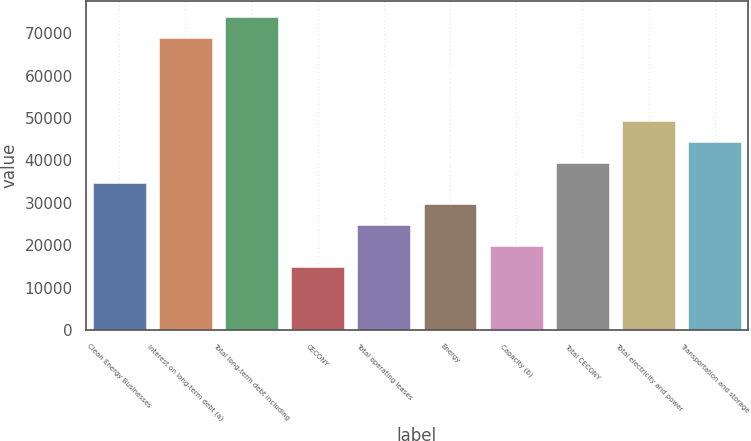Convert chart to OTSL. <chart><loc_0><loc_0><loc_500><loc_500><bar_chart><fcel>Clean Energy Businesses<fcel>Interest on long-term debt (a)<fcel>Total long-term debt including<fcel>CECONY<fcel>Total operating leases<fcel>Energy<fcel>Capacity (b)<fcel>Total CECONY<fcel>Total electricity and power<fcel>Transportation and storage<nl><fcel>34559.2<fcel>68870.4<fcel>73772<fcel>14952.8<fcel>24756<fcel>29657.6<fcel>19854.4<fcel>39460.8<fcel>49264<fcel>44362.4<nl></chart> 